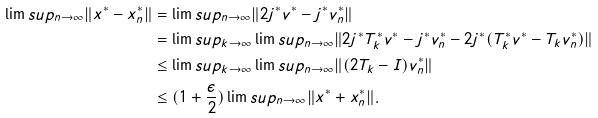Convert formula to latex. <formula><loc_0><loc_0><loc_500><loc_500>\lim s u p _ { n \to \infty } \| x ^ { * } - x _ { n } ^ { * } \| & = \lim s u p _ { n \to \infty } \| 2 j ^ { * } v ^ { * } - j ^ { * } v _ { n } ^ { * } \| \\ & = \lim s u p _ { k \to \infty } \lim s u p _ { n \to \infty } \| 2 j ^ { * } T _ { k } ^ { * } v ^ { * } - j ^ { * } v _ { n } ^ { * } - 2 j ^ { * } ( T _ { k } ^ { * } v ^ { * } - T _ { k } v _ { n } ^ { * } ) \| \\ & \leq \lim s u p _ { k \to \infty } \lim s u p _ { n \to \infty } \| ( 2 T _ { k } - I ) v _ { n } ^ { * } \| \\ & \leq ( 1 + \frac { \epsilon } { 2 } ) \lim s u p _ { n \to \infty } \| x ^ { * } + x _ { n } ^ { * } \| .</formula> 